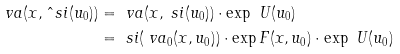Convert formula to latex. <formula><loc_0><loc_0><loc_500><loc_500>\ v a ( x , \hat { \ } s i ( u _ { 0 } ) ) & = \ v a ( x , \ s i ( u _ { 0 } ) ) \cdot \exp \ U ( u _ { 0 } ) \\ & = \ s i ( \ v a _ { 0 } ( x , u _ { 0 } ) ) \cdot \exp F ( x , u _ { 0 } ) \cdot \exp \ U ( u _ { 0 } )</formula> 